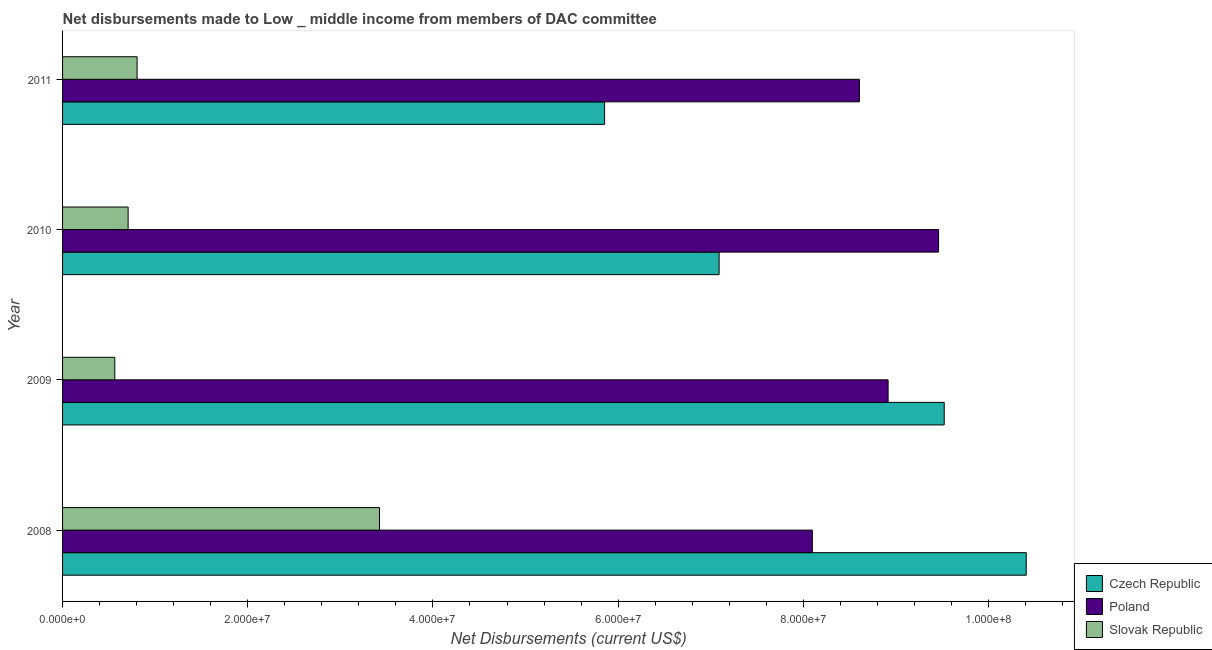Are the number of bars per tick equal to the number of legend labels?
Give a very brief answer. Yes. How many bars are there on the 4th tick from the bottom?
Provide a short and direct response. 3. What is the net disbursements made by slovak republic in 2011?
Your answer should be compact. 8.05e+06. Across all years, what is the maximum net disbursements made by slovak republic?
Give a very brief answer. 3.42e+07. Across all years, what is the minimum net disbursements made by czech republic?
Your answer should be very brief. 5.85e+07. In which year was the net disbursements made by slovak republic minimum?
Provide a succinct answer. 2009. What is the total net disbursements made by poland in the graph?
Keep it short and to the point. 3.51e+08. What is the difference between the net disbursements made by poland in 2008 and that in 2009?
Make the answer very short. -8.18e+06. What is the difference between the net disbursements made by poland in 2008 and the net disbursements made by czech republic in 2011?
Offer a terse response. 2.24e+07. What is the average net disbursements made by slovak republic per year?
Your answer should be very brief. 1.38e+07. In the year 2009, what is the difference between the net disbursements made by czech republic and net disbursements made by slovak republic?
Offer a very short reply. 8.96e+07. In how many years, is the net disbursements made by poland greater than 44000000 US$?
Your answer should be compact. 4. What is the ratio of the net disbursements made by czech republic in 2009 to that in 2010?
Provide a succinct answer. 1.34. What is the difference between the highest and the second highest net disbursements made by czech republic?
Your answer should be very brief. 8.86e+06. What is the difference between the highest and the lowest net disbursements made by poland?
Your answer should be compact. 1.36e+07. In how many years, is the net disbursements made by poland greater than the average net disbursements made by poland taken over all years?
Give a very brief answer. 2. What does the 2nd bar from the top in 2009 represents?
Offer a very short reply. Poland. What does the 3rd bar from the bottom in 2010 represents?
Ensure brevity in your answer.  Slovak Republic. Is it the case that in every year, the sum of the net disbursements made by czech republic and net disbursements made by poland is greater than the net disbursements made by slovak republic?
Give a very brief answer. Yes. Are the values on the major ticks of X-axis written in scientific E-notation?
Provide a short and direct response. Yes. Where does the legend appear in the graph?
Offer a terse response. Bottom right. What is the title of the graph?
Your answer should be very brief. Net disbursements made to Low _ middle income from members of DAC committee. What is the label or title of the X-axis?
Offer a terse response. Net Disbursements (current US$). What is the Net Disbursements (current US$) of Czech Republic in 2008?
Provide a succinct answer. 1.04e+08. What is the Net Disbursements (current US$) of Poland in 2008?
Keep it short and to the point. 8.10e+07. What is the Net Disbursements (current US$) of Slovak Republic in 2008?
Offer a terse response. 3.42e+07. What is the Net Disbursements (current US$) in Czech Republic in 2009?
Offer a terse response. 9.52e+07. What is the Net Disbursements (current US$) in Poland in 2009?
Provide a short and direct response. 8.92e+07. What is the Net Disbursements (current US$) in Slovak Republic in 2009?
Your response must be concise. 5.64e+06. What is the Net Disbursements (current US$) in Czech Republic in 2010?
Offer a terse response. 7.09e+07. What is the Net Disbursements (current US$) in Poland in 2010?
Give a very brief answer. 9.46e+07. What is the Net Disbursements (current US$) in Slovak Republic in 2010?
Keep it short and to the point. 7.08e+06. What is the Net Disbursements (current US$) in Czech Republic in 2011?
Provide a succinct answer. 5.85e+07. What is the Net Disbursements (current US$) of Poland in 2011?
Offer a terse response. 8.61e+07. What is the Net Disbursements (current US$) of Slovak Republic in 2011?
Your answer should be very brief. 8.05e+06. Across all years, what is the maximum Net Disbursements (current US$) in Czech Republic?
Make the answer very short. 1.04e+08. Across all years, what is the maximum Net Disbursements (current US$) of Poland?
Keep it short and to the point. 9.46e+07. Across all years, what is the maximum Net Disbursements (current US$) in Slovak Republic?
Provide a succinct answer. 3.42e+07. Across all years, what is the minimum Net Disbursements (current US$) in Czech Republic?
Your answer should be very brief. 5.85e+07. Across all years, what is the minimum Net Disbursements (current US$) in Poland?
Keep it short and to the point. 8.10e+07. Across all years, what is the minimum Net Disbursements (current US$) of Slovak Republic?
Give a very brief answer. 5.64e+06. What is the total Net Disbursements (current US$) in Czech Republic in the graph?
Make the answer very short. 3.29e+08. What is the total Net Disbursements (current US$) of Poland in the graph?
Give a very brief answer. 3.51e+08. What is the total Net Disbursements (current US$) in Slovak Republic in the graph?
Your answer should be very brief. 5.50e+07. What is the difference between the Net Disbursements (current US$) in Czech Republic in 2008 and that in 2009?
Provide a succinct answer. 8.86e+06. What is the difference between the Net Disbursements (current US$) of Poland in 2008 and that in 2009?
Provide a succinct answer. -8.18e+06. What is the difference between the Net Disbursements (current US$) of Slovak Republic in 2008 and that in 2009?
Give a very brief answer. 2.86e+07. What is the difference between the Net Disbursements (current US$) in Czech Republic in 2008 and that in 2010?
Your response must be concise. 3.32e+07. What is the difference between the Net Disbursements (current US$) in Poland in 2008 and that in 2010?
Keep it short and to the point. -1.36e+07. What is the difference between the Net Disbursements (current US$) of Slovak Republic in 2008 and that in 2010?
Provide a short and direct response. 2.72e+07. What is the difference between the Net Disbursements (current US$) in Czech Republic in 2008 and that in 2011?
Offer a very short reply. 4.55e+07. What is the difference between the Net Disbursements (current US$) of Poland in 2008 and that in 2011?
Give a very brief answer. -5.08e+06. What is the difference between the Net Disbursements (current US$) of Slovak Republic in 2008 and that in 2011?
Make the answer very short. 2.62e+07. What is the difference between the Net Disbursements (current US$) of Czech Republic in 2009 and that in 2010?
Provide a short and direct response. 2.43e+07. What is the difference between the Net Disbursements (current US$) in Poland in 2009 and that in 2010?
Your response must be concise. -5.45e+06. What is the difference between the Net Disbursements (current US$) of Slovak Republic in 2009 and that in 2010?
Give a very brief answer. -1.44e+06. What is the difference between the Net Disbursements (current US$) in Czech Republic in 2009 and that in 2011?
Ensure brevity in your answer.  3.67e+07. What is the difference between the Net Disbursements (current US$) of Poland in 2009 and that in 2011?
Your answer should be very brief. 3.10e+06. What is the difference between the Net Disbursements (current US$) in Slovak Republic in 2009 and that in 2011?
Provide a short and direct response. -2.41e+06. What is the difference between the Net Disbursements (current US$) in Czech Republic in 2010 and that in 2011?
Ensure brevity in your answer.  1.24e+07. What is the difference between the Net Disbursements (current US$) of Poland in 2010 and that in 2011?
Your response must be concise. 8.55e+06. What is the difference between the Net Disbursements (current US$) of Slovak Republic in 2010 and that in 2011?
Offer a very short reply. -9.70e+05. What is the difference between the Net Disbursements (current US$) of Czech Republic in 2008 and the Net Disbursements (current US$) of Poland in 2009?
Ensure brevity in your answer.  1.49e+07. What is the difference between the Net Disbursements (current US$) of Czech Republic in 2008 and the Net Disbursements (current US$) of Slovak Republic in 2009?
Make the answer very short. 9.84e+07. What is the difference between the Net Disbursements (current US$) in Poland in 2008 and the Net Disbursements (current US$) in Slovak Republic in 2009?
Offer a terse response. 7.53e+07. What is the difference between the Net Disbursements (current US$) of Czech Republic in 2008 and the Net Disbursements (current US$) of Poland in 2010?
Offer a terse response. 9.47e+06. What is the difference between the Net Disbursements (current US$) of Czech Republic in 2008 and the Net Disbursements (current US$) of Slovak Republic in 2010?
Ensure brevity in your answer.  9.70e+07. What is the difference between the Net Disbursements (current US$) in Poland in 2008 and the Net Disbursements (current US$) in Slovak Republic in 2010?
Your response must be concise. 7.39e+07. What is the difference between the Net Disbursements (current US$) of Czech Republic in 2008 and the Net Disbursements (current US$) of Poland in 2011?
Your answer should be compact. 1.80e+07. What is the difference between the Net Disbursements (current US$) in Czech Republic in 2008 and the Net Disbursements (current US$) in Slovak Republic in 2011?
Your response must be concise. 9.60e+07. What is the difference between the Net Disbursements (current US$) of Poland in 2008 and the Net Disbursements (current US$) of Slovak Republic in 2011?
Your answer should be compact. 7.29e+07. What is the difference between the Net Disbursements (current US$) in Czech Republic in 2009 and the Net Disbursements (current US$) in Poland in 2010?
Make the answer very short. 6.10e+05. What is the difference between the Net Disbursements (current US$) in Czech Republic in 2009 and the Net Disbursements (current US$) in Slovak Republic in 2010?
Give a very brief answer. 8.81e+07. What is the difference between the Net Disbursements (current US$) of Poland in 2009 and the Net Disbursements (current US$) of Slovak Republic in 2010?
Offer a terse response. 8.21e+07. What is the difference between the Net Disbursements (current US$) of Czech Republic in 2009 and the Net Disbursements (current US$) of Poland in 2011?
Your answer should be very brief. 9.16e+06. What is the difference between the Net Disbursements (current US$) of Czech Republic in 2009 and the Net Disbursements (current US$) of Slovak Republic in 2011?
Offer a very short reply. 8.72e+07. What is the difference between the Net Disbursements (current US$) of Poland in 2009 and the Net Disbursements (current US$) of Slovak Republic in 2011?
Provide a succinct answer. 8.11e+07. What is the difference between the Net Disbursements (current US$) in Czech Republic in 2010 and the Net Disbursements (current US$) in Poland in 2011?
Provide a short and direct response. -1.52e+07. What is the difference between the Net Disbursements (current US$) of Czech Republic in 2010 and the Net Disbursements (current US$) of Slovak Republic in 2011?
Provide a short and direct response. 6.29e+07. What is the difference between the Net Disbursements (current US$) in Poland in 2010 and the Net Disbursements (current US$) in Slovak Republic in 2011?
Your answer should be very brief. 8.66e+07. What is the average Net Disbursements (current US$) of Czech Republic per year?
Offer a very short reply. 8.22e+07. What is the average Net Disbursements (current US$) in Poland per year?
Make the answer very short. 8.77e+07. What is the average Net Disbursements (current US$) in Slovak Republic per year?
Give a very brief answer. 1.38e+07. In the year 2008, what is the difference between the Net Disbursements (current US$) of Czech Republic and Net Disbursements (current US$) of Poland?
Make the answer very short. 2.31e+07. In the year 2008, what is the difference between the Net Disbursements (current US$) of Czech Republic and Net Disbursements (current US$) of Slovak Republic?
Offer a very short reply. 6.98e+07. In the year 2008, what is the difference between the Net Disbursements (current US$) in Poland and Net Disbursements (current US$) in Slovak Republic?
Provide a succinct answer. 4.68e+07. In the year 2009, what is the difference between the Net Disbursements (current US$) in Czech Republic and Net Disbursements (current US$) in Poland?
Your answer should be very brief. 6.06e+06. In the year 2009, what is the difference between the Net Disbursements (current US$) in Czech Republic and Net Disbursements (current US$) in Slovak Republic?
Your response must be concise. 8.96e+07. In the year 2009, what is the difference between the Net Disbursements (current US$) in Poland and Net Disbursements (current US$) in Slovak Republic?
Your answer should be very brief. 8.35e+07. In the year 2010, what is the difference between the Net Disbursements (current US$) of Czech Republic and Net Disbursements (current US$) of Poland?
Your answer should be very brief. -2.37e+07. In the year 2010, what is the difference between the Net Disbursements (current US$) of Czech Republic and Net Disbursements (current US$) of Slovak Republic?
Your answer should be very brief. 6.38e+07. In the year 2010, what is the difference between the Net Disbursements (current US$) in Poland and Net Disbursements (current US$) in Slovak Republic?
Keep it short and to the point. 8.75e+07. In the year 2011, what is the difference between the Net Disbursements (current US$) of Czech Republic and Net Disbursements (current US$) of Poland?
Give a very brief answer. -2.75e+07. In the year 2011, what is the difference between the Net Disbursements (current US$) of Czech Republic and Net Disbursements (current US$) of Slovak Republic?
Your answer should be compact. 5.05e+07. In the year 2011, what is the difference between the Net Disbursements (current US$) of Poland and Net Disbursements (current US$) of Slovak Republic?
Offer a very short reply. 7.80e+07. What is the ratio of the Net Disbursements (current US$) in Czech Republic in 2008 to that in 2009?
Ensure brevity in your answer.  1.09. What is the ratio of the Net Disbursements (current US$) in Poland in 2008 to that in 2009?
Your answer should be very brief. 0.91. What is the ratio of the Net Disbursements (current US$) in Slovak Republic in 2008 to that in 2009?
Your response must be concise. 6.07. What is the ratio of the Net Disbursements (current US$) in Czech Republic in 2008 to that in 2010?
Make the answer very short. 1.47. What is the ratio of the Net Disbursements (current US$) in Poland in 2008 to that in 2010?
Give a very brief answer. 0.86. What is the ratio of the Net Disbursements (current US$) of Slovak Republic in 2008 to that in 2010?
Your answer should be very brief. 4.83. What is the ratio of the Net Disbursements (current US$) in Czech Republic in 2008 to that in 2011?
Provide a succinct answer. 1.78. What is the ratio of the Net Disbursements (current US$) in Poland in 2008 to that in 2011?
Offer a very short reply. 0.94. What is the ratio of the Net Disbursements (current US$) of Slovak Republic in 2008 to that in 2011?
Offer a very short reply. 4.25. What is the ratio of the Net Disbursements (current US$) in Czech Republic in 2009 to that in 2010?
Ensure brevity in your answer.  1.34. What is the ratio of the Net Disbursements (current US$) of Poland in 2009 to that in 2010?
Provide a succinct answer. 0.94. What is the ratio of the Net Disbursements (current US$) in Slovak Republic in 2009 to that in 2010?
Make the answer very short. 0.8. What is the ratio of the Net Disbursements (current US$) in Czech Republic in 2009 to that in 2011?
Ensure brevity in your answer.  1.63. What is the ratio of the Net Disbursements (current US$) in Poland in 2009 to that in 2011?
Offer a terse response. 1.04. What is the ratio of the Net Disbursements (current US$) of Slovak Republic in 2009 to that in 2011?
Your answer should be compact. 0.7. What is the ratio of the Net Disbursements (current US$) of Czech Republic in 2010 to that in 2011?
Your answer should be compact. 1.21. What is the ratio of the Net Disbursements (current US$) in Poland in 2010 to that in 2011?
Give a very brief answer. 1.1. What is the ratio of the Net Disbursements (current US$) in Slovak Republic in 2010 to that in 2011?
Offer a terse response. 0.88. What is the difference between the highest and the second highest Net Disbursements (current US$) of Czech Republic?
Your answer should be compact. 8.86e+06. What is the difference between the highest and the second highest Net Disbursements (current US$) of Poland?
Give a very brief answer. 5.45e+06. What is the difference between the highest and the second highest Net Disbursements (current US$) in Slovak Republic?
Offer a terse response. 2.62e+07. What is the difference between the highest and the lowest Net Disbursements (current US$) in Czech Republic?
Provide a succinct answer. 4.55e+07. What is the difference between the highest and the lowest Net Disbursements (current US$) of Poland?
Offer a terse response. 1.36e+07. What is the difference between the highest and the lowest Net Disbursements (current US$) of Slovak Republic?
Provide a succinct answer. 2.86e+07. 